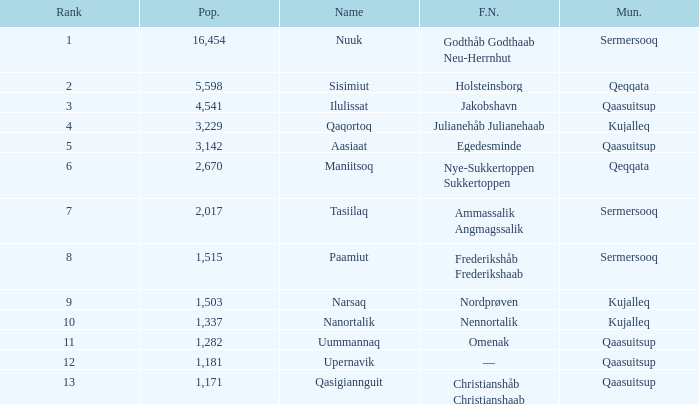Who has a former name of nordprøven? Narsaq. 